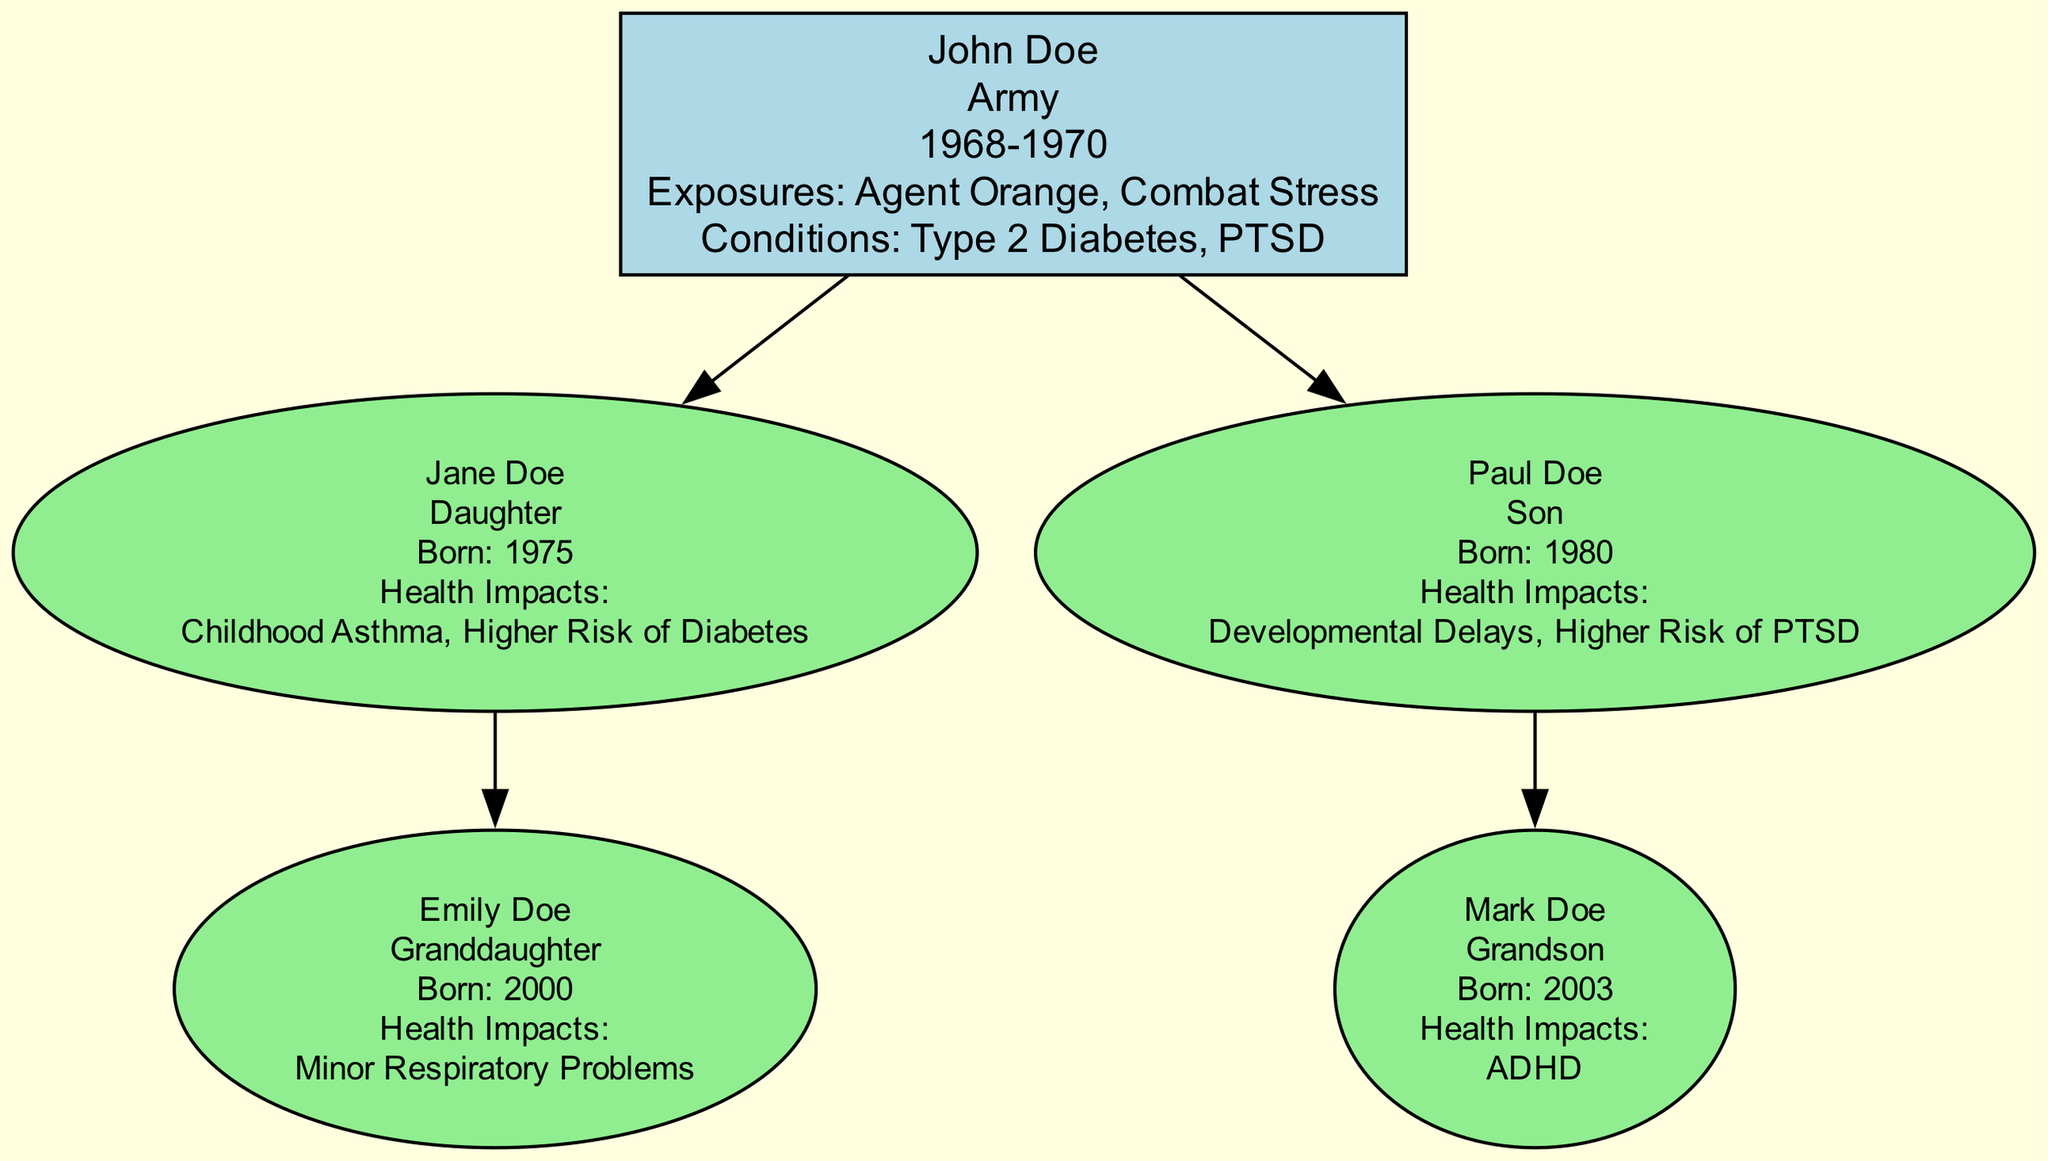What is the name of the root person in the family tree? The root person in the family tree is John Doe, as indicated at the top of the diagram.
Answer: John Doe What branch of military service did John Doe serve in? The diagram specifies that John Doe served in the Army, which is shown in his service details.
Answer: Army How many children does John Doe have? By examining the descendants listed under John Doe, there are two children: Jane Doe and Paul Doe.
Answer: Two What health impact is associated with Paul Doe? The health impacts listed for Paul Doe include Developmental Delays and Higher Risk of PTSD; either of these can be an appropriate answer for this query.
Answer: Developmental Delays Which condition is shared between John Doe and his daughter Jane Doe? Both John Doe and his daughter Jane Doe have a higher risk of Diabetes, which relates to John's chronic condition of Type 2 Diabetes and Jane's health impacts.
Answer: Higher Risk of Diabetes How many grandchildren does John Doe have? The family tree indicates two grandchildren: Emily Doe and Mark Doe, who are children of Jane Doe and Paul Doe, respectively.
Answer: Two What is the birth year of the oldest descendant? The oldest descendant listed in the diagram is Jane Doe, born in 1975; she is also the only daughter, which helps identify her as the oldest among the descendants.
Answer: 1975 What are the notable exposures of John Doe during his military service? The diagram explicitly states that John Doe was exposed to Agent Orange and Combat Stress during his service, as indicated in the service details.
Answer: Agent Orange, Combat Stress Which descendant has ADHD listed as a health impact? Mark Doe is identified as the grandchild who has ADHD as one of his health impacts in the diagram under his health details.
Answer: Mark Doe 